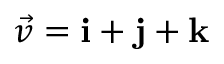Convert formula to latex. <formula><loc_0><loc_0><loc_500><loc_500>{ \vec { v } } = i + j + k</formula> 